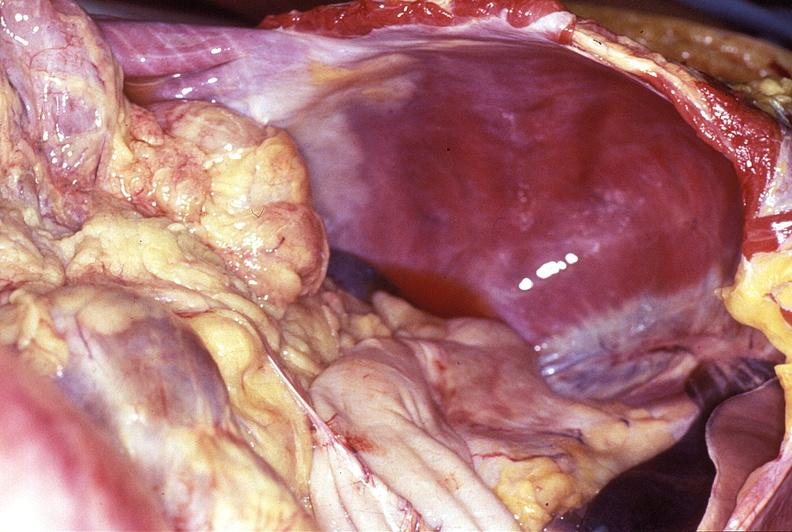does this image show intestine, volvulus?
Answer the question using a single word or phrase. Yes 